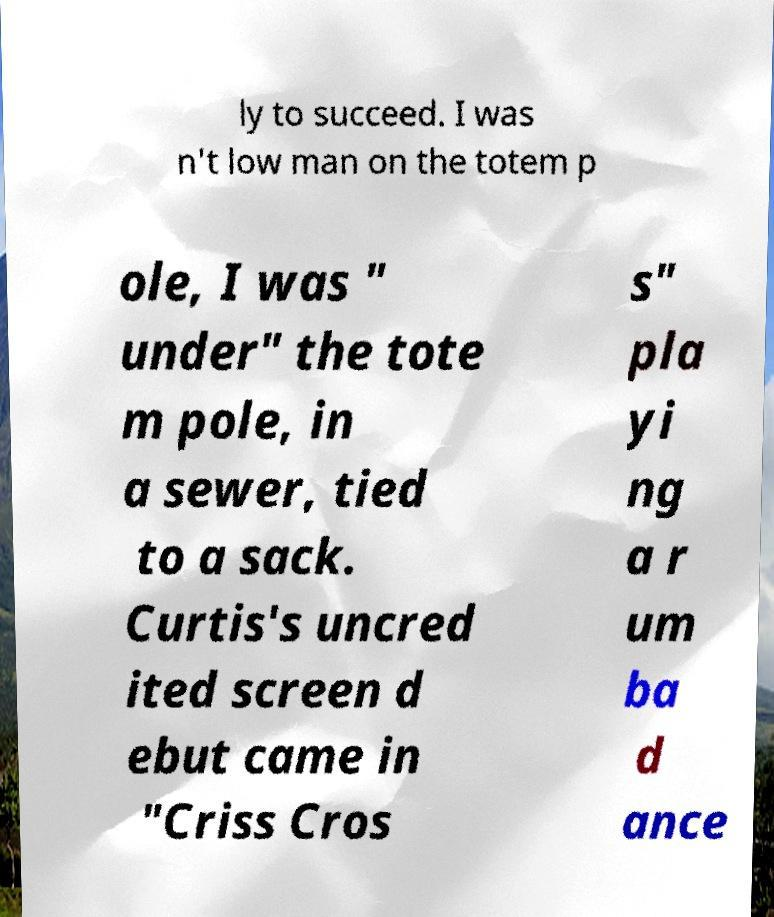I need the written content from this picture converted into text. Can you do that? ly to succeed. I was n't low man on the totem p ole, I was " under" the tote m pole, in a sewer, tied to a sack. Curtis's uncred ited screen d ebut came in "Criss Cros s" pla yi ng a r um ba d ance 